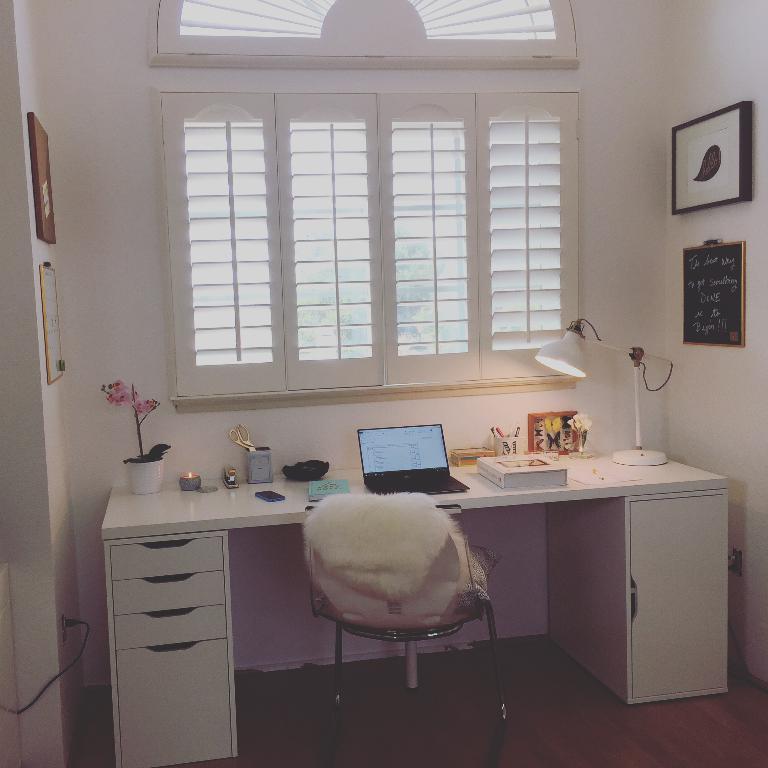Could you give a brief overview of what you see in this image? In the image in the center we can see the table,on table we can see some objects like laptop,book and pot etc. And in center there is a chair. Coming to the background we can see the window and wall with the photo frames. 